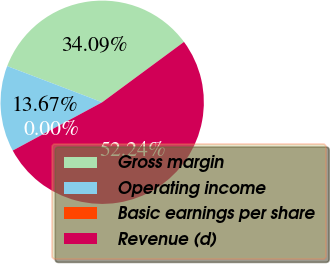Convert chart. <chart><loc_0><loc_0><loc_500><loc_500><pie_chart><fcel>Gross margin<fcel>Operating income<fcel>Basic earnings per share<fcel>Revenue (d)<nl><fcel>34.09%<fcel>13.67%<fcel>0.0%<fcel>52.24%<nl></chart> 